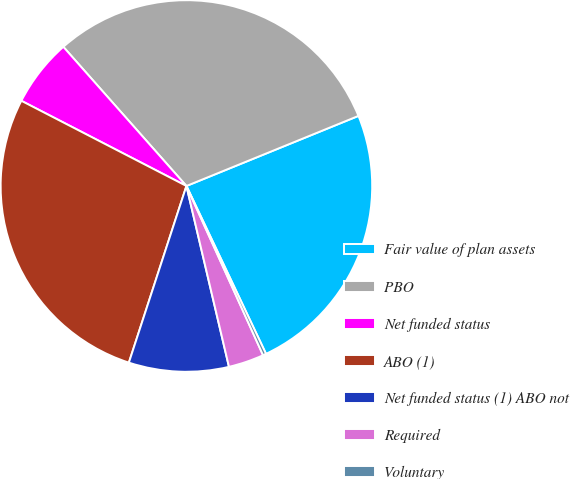<chart> <loc_0><loc_0><loc_500><loc_500><pie_chart><fcel>Fair value of plan assets<fcel>PBO<fcel>Net funded status<fcel>ABO (1)<fcel>Net funded status (1) ABO not<fcel>Required<fcel>Voluntary<nl><fcel>24.11%<fcel>30.37%<fcel>5.89%<fcel>27.57%<fcel>8.69%<fcel>3.09%<fcel>0.28%<nl></chart> 